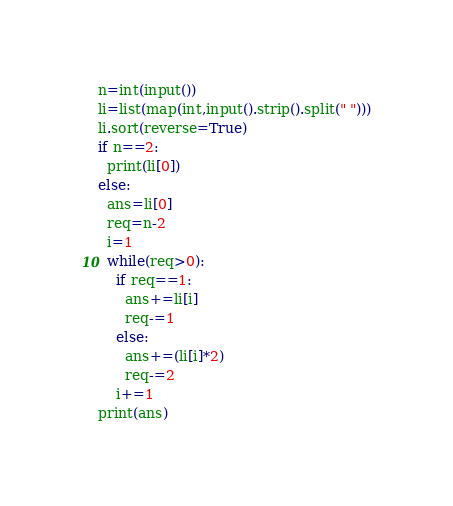Convert code to text. <code><loc_0><loc_0><loc_500><loc_500><_Python_>n=int(input())
li=list(map(int,input().strip().split(" ")))
li.sort(reverse=True)
if n==2:
  print(li[0])
else:
  ans=li[0]
  req=n-2
  i=1
  while(req>0):
    if req==1:
      ans+=li[i]
      req-=1
    else:
      ans+=(li[i]*2)
      req-=2
    i+=1
print(ans)

</code> 